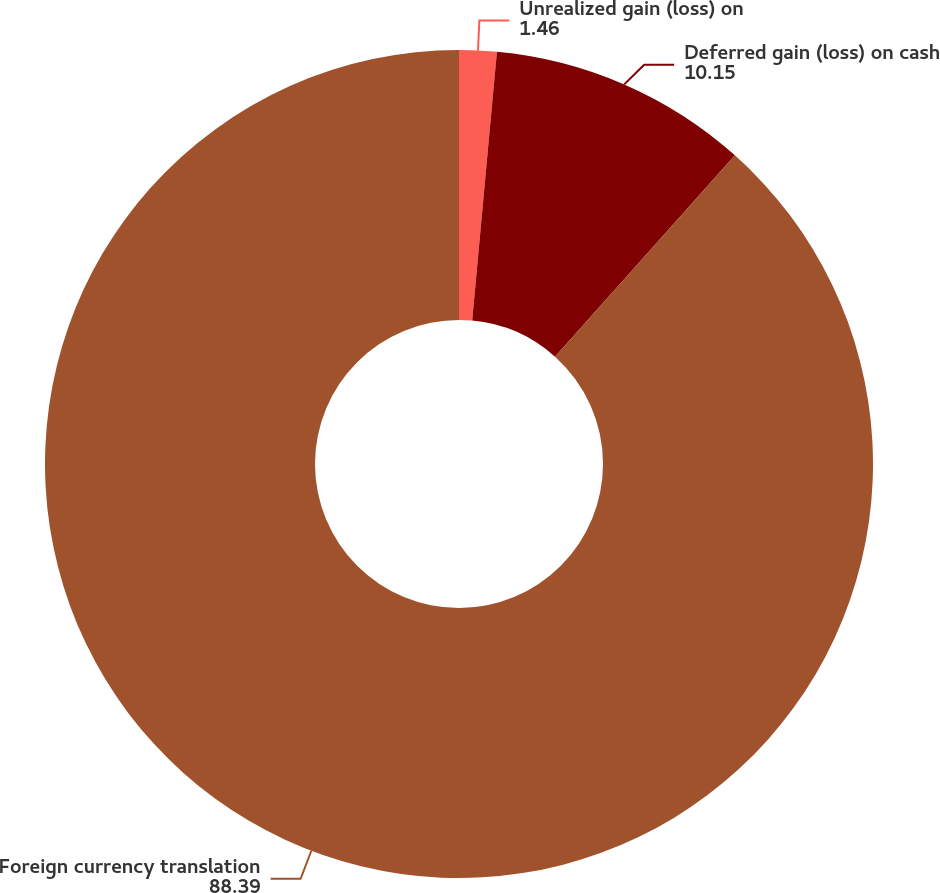<chart> <loc_0><loc_0><loc_500><loc_500><pie_chart><fcel>Unrealized gain (loss) on<fcel>Deferred gain (loss) on cash<fcel>Foreign currency translation<nl><fcel>1.46%<fcel>10.15%<fcel>88.39%<nl></chart> 